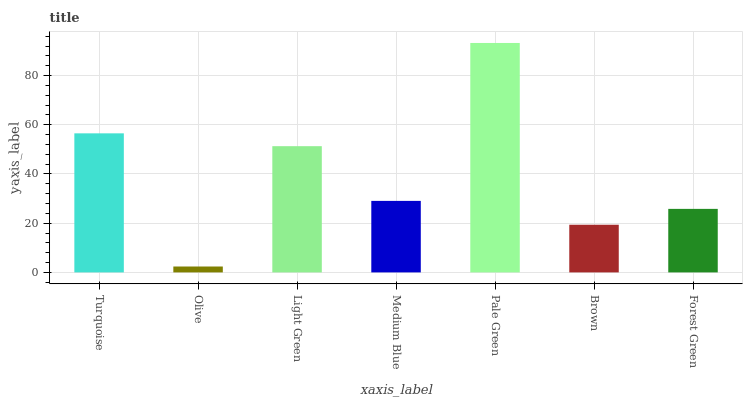Is Olive the minimum?
Answer yes or no. Yes. Is Pale Green the maximum?
Answer yes or no. Yes. Is Light Green the minimum?
Answer yes or no. No. Is Light Green the maximum?
Answer yes or no. No. Is Light Green greater than Olive?
Answer yes or no. Yes. Is Olive less than Light Green?
Answer yes or no. Yes. Is Olive greater than Light Green?
Answer yes or no. No. Is Light Green less than Olive?
Answer yes or no. No. Is Medium Blue the high median?
Answer yes or no. Yes. Is Medium Blue the low median?
Answer yes or no. Yes. Is Turquoise the high median?
Answer yes or no. No. Is Turquoise the low median?
Answer yes or no. No. 